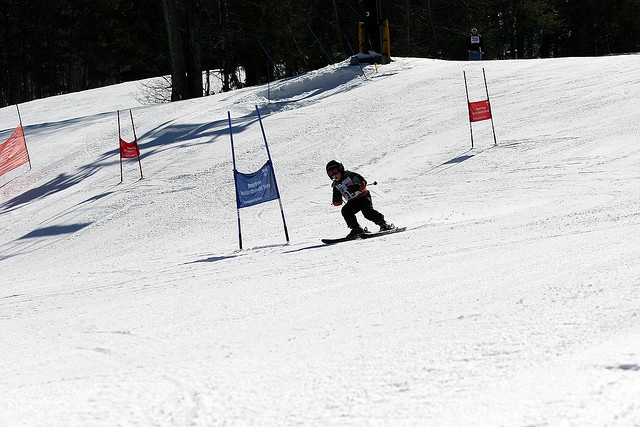Describe the objects in this image and their specific colors. I can see people in black, gray, maroon, and white tones, skis in black, gray, lightgray, and darkgray tones, and people in black, gray, and navy tones in this image. 